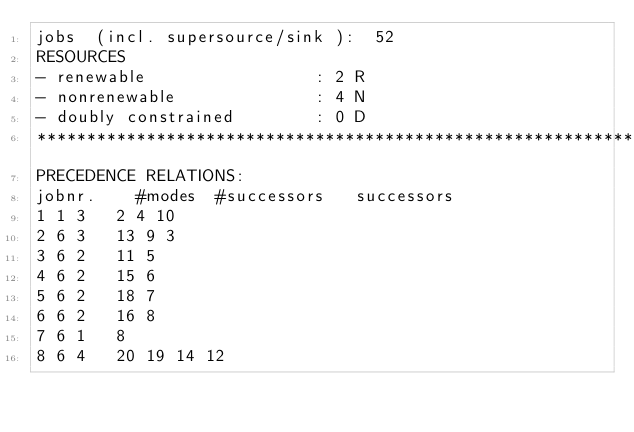<code> <loc_0><loc_0><loc_500><loc_500><_ObjectiveC_>jobs  (incl. supersource/sink ):	52
RESOURCES
- renewable                 : 2 R
- nonrenewable              : 4 N
- doubly constrained        : 0 D
************************************************************************
PRECEDENCE RELATIONS:
jobnr.    #modes  #successors   successors
1	1	3		2 4 10 
2	6	3		13 9 3 
3	6	2		11 5 
4	6	2		15 6 
5	6	2		18 7 
6	6	2		16 8 
7	6	1		8 
8	6	4		20 19 14 12 </code> 